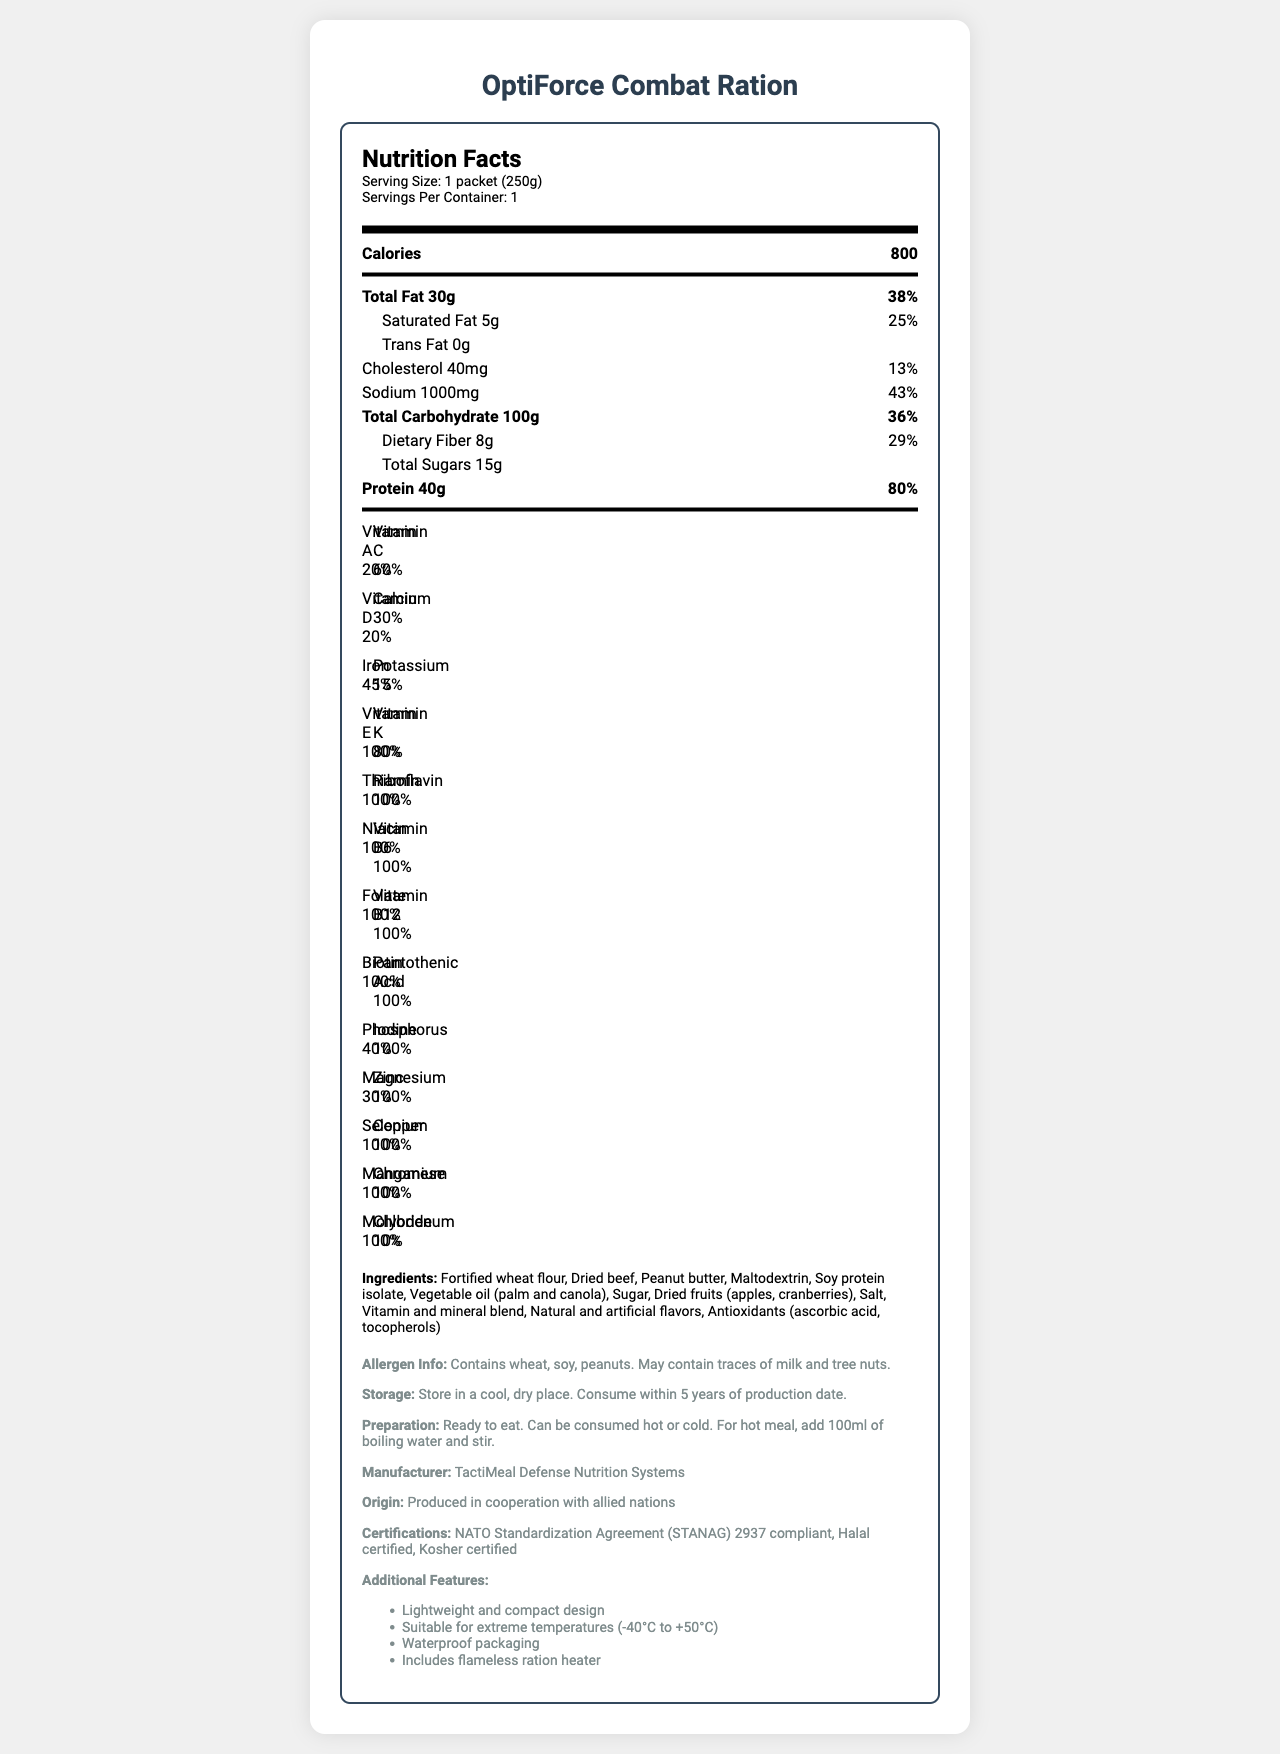what is the serving size? The serving size is explicitly mentioned at the top of the Nutrition Facts section of the label.
Answer: 1 packet (250g) how many calories are in one serving? The calorie count per serving is clearly listed under the nutrition header.
Answer: 800 what is the total fat content in one packet? The total fat content is stated in the nutrition facts section.
Answer: 30g what percentage of the daily value of sodium does one packet contain? The percentage of daily value for sodium is listed under the sodium content in the nutrition facts section.
Answer: 43% how should this product be stored? The storage instructions are included in the additional information section of the document.
Answer: Store in a cool, dry place. Consume within 5 years of production date. what allergens are present in this product? A. Wheat, Soy, and Peanuts B. Milk and Tree Nuts C. Fish and Shellfish D. All of the above The allergen information mentions that the product contains wheat, soy, and peanuts and may contain traces of milk and tree nuts.
Answer: A what are the main ingredients in OptiForce Combat Ration? A. Wheat flour, beef, peanut butter B. Chocolate, nuts, fruit C. Bread, cheese, ham D. Rice, beans, vegetables The ingredients list shows fortified wheat flour, dried beef, and peanut butter among others.
Answer: A is this product suitable for extreme temperatures? The additional features list mentions that it is suitable for extreme temperatures (-40°C to +50°C).
Answer: Yes is this product compliant with any NATO standards? The document specifies it is compliant with NATO Standardization Agreement (STANAG) 2937.
Answer: Yes summarize the main features and nutritional information of this product. The document provides comprehensive nutritional information, storage, preparation instructions, manufacturer details, certifications, and features.
Answer: The OptiForce Combat Ration is a nutrient-dense, lightweight field ration optimized for extended deployments. It provides 800 calories per packet, containing 30g of total fat, 40g of protein, significant amounts of vitamins, and is suitable for extreme temperatures. It includes a flameless ration heater and is compliant with NATO standards. how much calcium does one serving provide in terms of the daily value? The daily value percentage for calcium is clearly listed under the vitamins and minerals section.
Answer: 30% what is the recommended amount of water to add for a hot meal preparation? The preparation instructions indicate adding 100ml of boiling water and stirring.
Answer: 100ml can I consume this product if I have a tree nut allergy? The allergen information specifies that the product may contain traces of tree nuts.
Answer: It may contain traces of tree nuts who manufactures OptiForce Combat Ration? The manufacturer is listed in the additional information section.
Answer: TactiMeal Defense Nutrition Systems how long is this product suitable for consumption after its production date? The storage instructions mention that the product should be consumed within 5 years of production.
Answer: 5 years where is this product produced? The country of origin is specified in the additional information section.
Answer: Produced in cooperation with allied nations what certifications does this product have? The certifications are clearly listed in the additional information section.
Answer: NATO Standardization Agreement (STANAG) 2937 compliant, Halal certified, Kosher certified what is the percentage of daily value for dietary fiber per packet? The daily value percentage for dietary fiber is provided under the dietary fiber content in the nutrition facts section.
Answer: 29% is the vitamin K content in this product higher than the vitamin D content? Vitamin K is 80% of daily value, whereas Vitamin D is 20%.
Answer: Yes does this product include any artificial flavors? The ingredients list mentions natural and artificial flavors.
Answer: Yes what is the phosphorus content in terms of daily value? The daily value percentage for phosphorus is listed under the vitamins and minerals section.
Answer: 40% which of the following minerals is not listed in the document: chromium or cobalt? Chromium is listed, but cobalt is not mentioned in the vitamins and minerals section.
Answer: Cobalt can this ration be consumed without heating? The preparation instructions state that the product can be consumed hot or cold.
Answer: Yes what is the protein content in one serving of this product? The protein content is stated in the nutrition facts section.
Answer: 40g how is the product packaging designed for field conditions? The additional features specify that the packaging is designed to be lightweight, compact, and waterproof.
Answer: Lightweight and compact design, Waterproof packaging 